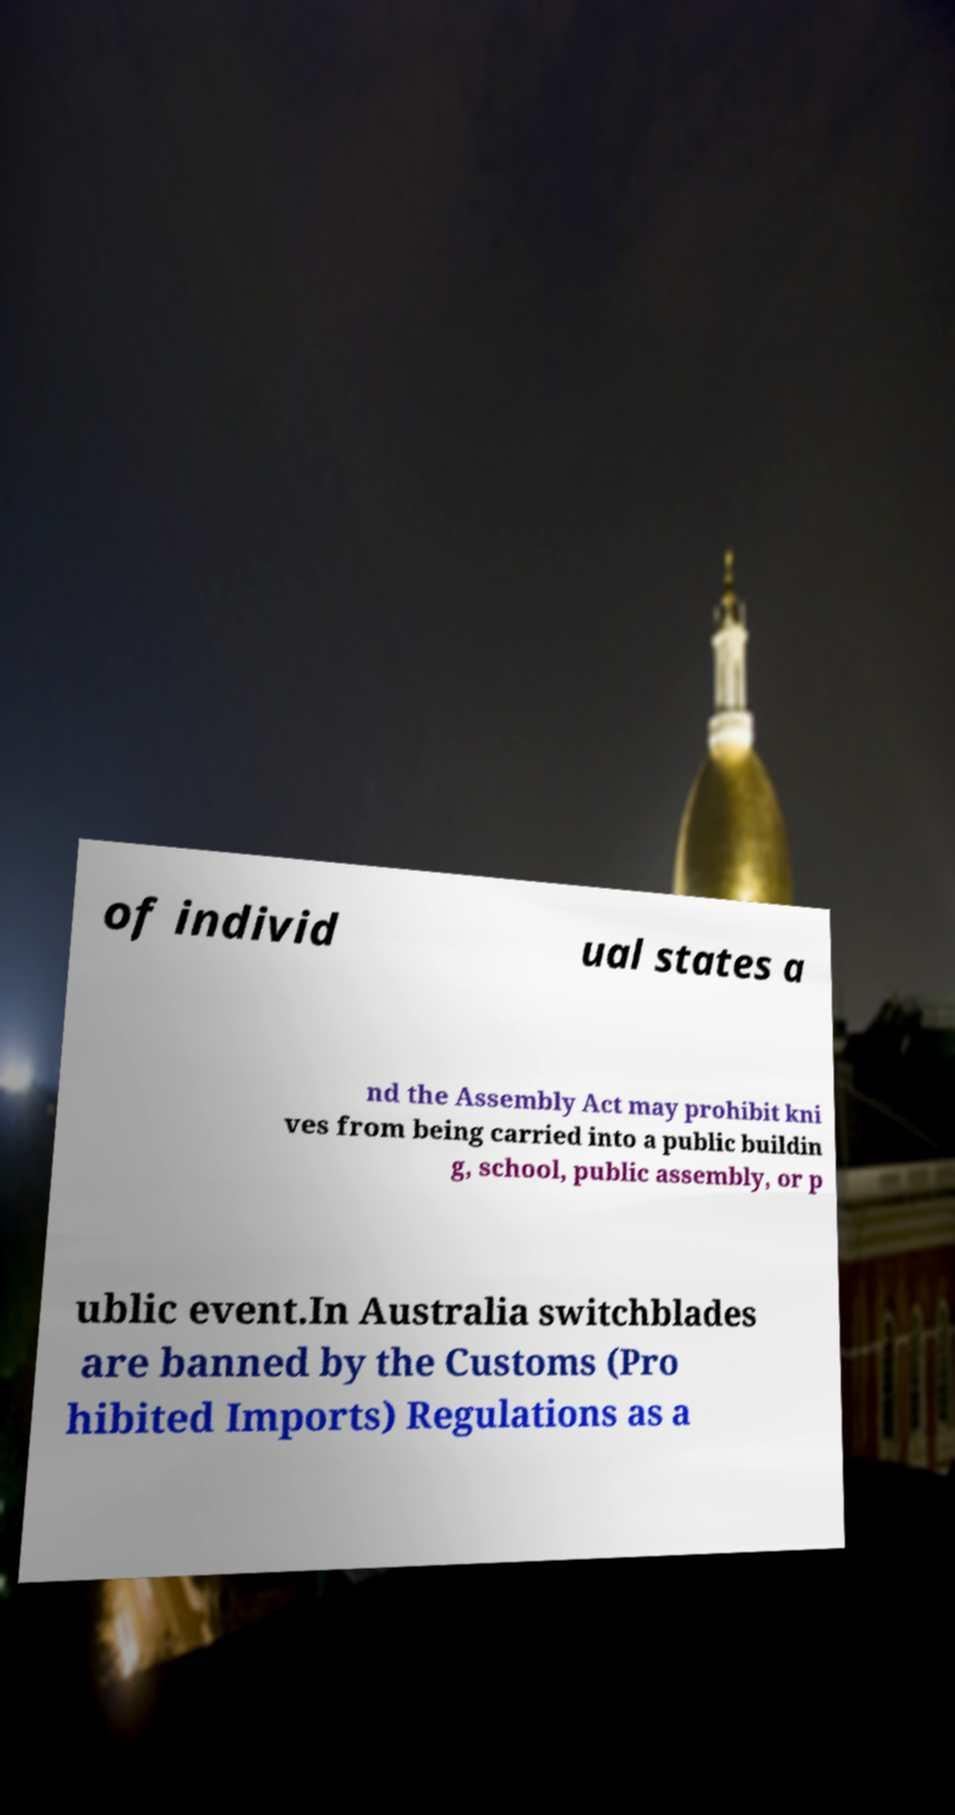Could you extract and type out the text from this image? of individ ual states a nd the Assembly Act may prohibit kni ves from being carried into a public buildin g, school, public assembly, or p ublic event.In Australia switchblades are banned by the Customs (Pro hibited Imports) Regulations as a 